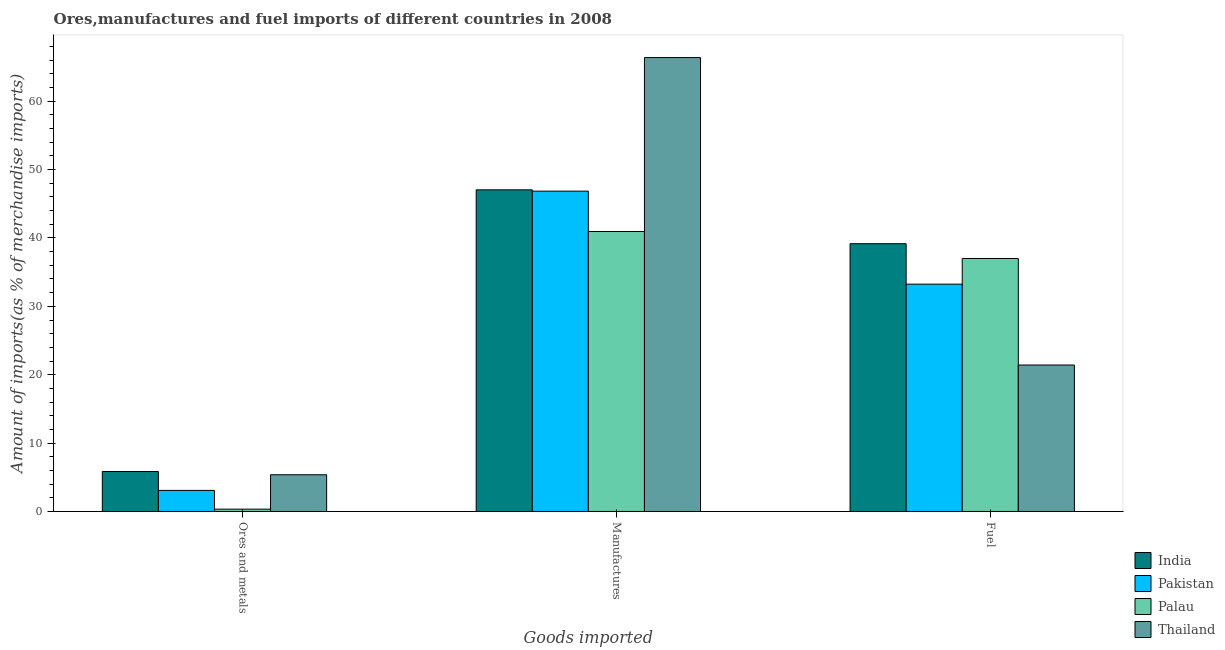How many groups of bars are there?
Offer a terse response. 3. Are the number of bars per tick equal to the number of legend labels?
Keep it short and to the point. Yes. How many bars are there on the 1st tick from the left?
Provide a short and direct response. 4. What is the label of the 1st group of bars from the left?
Give a very brief answer. Ores and metals. What is the percentage of fuel imports in India?
Your answer should be very brief. 39.16. Across all countries, what is the maximum percentage of manufactures imports?
Provide a succinct answer. 66.38. Across all countries, what is the minimum percentage of fuel imports?
Ensure brevity in your answer.  21.42. In which country was the percentage of ores and metals imports maximum?
Your response must be concise. India. In which country was the percentage of manufactures imports minimum?
Offer a very short reply. Palau. What is the total percentage of ores and metals imports in the graph?
Your response must be concise. 14.64. What is the difference between the percentage of manufactures imports in Pakistan and that in India?
Your response must be concise. -0.19. What is the difference between the percentage of fuel imports in Pakistan and the percentage of manufactures imports in Palau?
Offer a very short reply. -7.7. What is the average percentage of manufactures imports per country?
Ensure brevity in your answer.  50.31. What is the difference between the percentage of fuel imports and percentage of ores and metals imports in Palau?
Your answer should be very brief. 36.66. In how many countries, is the percentage of ores and metals imports greater than 22 %?
Keep it short and to the point. 0. What is the ratio of the percentage of fuel imports in Palau to that in Thailand?
Give a very brief answer. 1.73. Is the percentage of manufactures imports in Palau less than that in India?
Provide a short and direct response. Yes. What is the difference between the highest and the second highest percentage of fuel imports?
Your answer should be very brief. 2.16. What is the difference between the highest and the lowest percentage of manufactures imports?
Provide a succinct answer. 25.44. In how many countries, is the percentage of fuel imports greater than the average percentage of fuel imports taken over all countries?
Your answer should be very brief. 3. Is the sum of the percentage of ores and metals imports in Pakistan and India greater than the maximum percentage of manufactures imports across all countries?
Offer a very short reply. No. What does the 2nd bar from the left in Ores and metals represents?
Provide a succinct answer. Pakistan. What does the 3rd bar from the right in Manufactures represents?
Provide a succinct answer. Pakistan. How many bars are there?
Offer a very short reply. 12. How many countries are there in the graph?
Ensure brevity in your answer.  4. Does the graph contain any zero values?
Your answer should be compact. No. Where does the legend appear in the graph?
Provide a short and direct response. Bottom right. How are the legend labels stacked?
Your answer should be compact. Vertical. What is the title of the graph?
Keep it short and to the point. Ores,manufactures and fuel imports of different countries in 2008. Does "Rwanda" appear as one of the legend labels in the graph?
Your answer should be compact. No. What is the label or title of the X-axis?
Offer a very short reply. Goods imported. What is the label or title of the Y-axis?
Keep it short and to the point. Amount of imports(as % of merchandise imports). What is the Amount of imports(as % of merchandise imports) of India in Ores and metals?
Keep it short and to the point. 5.85. What is the Amount of imports(as % of merchandise imports) in Pakistan in Ores and metals?
Provide a short and direct response. 3.08. What is the Amount of imports(as % of merchandise imports) of Palau in Ores and metals?
Keep it short and to the point. 0.34. What is the Amount of imports(as % of merchandise imports) in Thailand in Ores and metals?
Your answer should be compact. 5.37. What is the Amount of imports(as % of merchandise imports) of India in Manufactures?
Offer a very short reply. 47.04. What is the Amount of imports(as % of merchandise imports) of Pakistan in Manufactures?
Ensure brevity in your answer.  46.85. What is the Amount of imports(as % of merchandise imports) in Palau in Manufactures?
Your answer should be very brief. 40.95. What is the Amount of imports(as % of merchandise imports) in Thailand in Manufactures?
Offer a terse response. 66.38. What is the Amount of imports(as % of merchandise imports) of India in Fuel?
Offer a terse response. 39.16. What is the Amount of imports(as % of merchandise imports) in Pakistan in Fuel?
Provide a succinct answer. 33.25. What is the Amount of imports(as % of merchandise imports) in Palau in Fuel?
Provide a short and direct response. 37. What is the Amount of imports(as % of merchandise imports) in Thailand in Fuel?
Provide a short and direct response. 21.42. Across all Goods imported, what is the maximum Amount of imports(as % of merchandise imports) in India?
Offer a terse response. 47.04. Across all Goods imported, what is the maximum Amount of imports(as % of merchandise imports) of Pakistan?
Offer a terse response. 46.85. Across all Goods imported, what is the maximum Amount of imports(as % of merchandise imports) of Palau?
Your answer should be very brief. 40.95. Across all Goods imported, what is the maximum Amount of imports(as % of merchandise imports) in Thailand?
Offer a very short reply. 66.38. Across all Goods imported, what is the minimum Amount of imports(as % of merchandise imports) of India?
Provide a short and direct response. 5.85. Across all Goods imported, what is the minimum Amount of imports(as % of merchandise imports) of Pakistan?
Ensure brevity in your answer.  3.08. Across all Goods imported, what is the minimum Amount of imports(as % of merchandise imports) in Palau?
Provide a short and direct response. 0.34. Across all Goods imported, what is the minimum Amount of imports(as % of merchandise imports) in Thailand?
Make the answer very short. 5.37. What is the total Amount of imports(as % of merchandise imports) in India in the graph?
Your answer should be very brief. 92.05. What is the total Amount of imports(as % of merchandise imports) in Pakistan in the graph?
Your answer should be very brief. 83.18. What is the total Amount of imports(as % of merchandise imports) of Palau in the graph?
Your response must be concise. 78.29. What is the total Amount of imports(as % of merchandise imports) of Thailand in the graph?
Your answer should be very brief. 93.17. What is the difference between the Amount of imports(as % of merchandise imports) of India in Ores and metals and that in Manufactures?
Keep it short and to the point. -41.19. What is the difference between the Amount of imports(as % of merchandise imports) in Pakistan in Ores and metals and that in Manufactures?
Offer a terse response. -43.77. What is the difference between the Amount of imports(as % of merchandise imports) in Palau in Ores and metals and that in Manufactures?
Ensure brevity in your answer.  -40.61. What is the difference between the Amount of imports(as % of merchandise imports) in Thailand in Ores and metals and that in Manufactures?
Give a very brief answer. -61.01. What is the difference between the Amount of imports(as % of merchandise imports) in India in Ores and metals and that in Fuel?
Provide a succinct answer. -33.32. What is the difference between the Amount of imports(as % of merchandise imports) of Pakistan in Ores and metals and that in Fuel?
Offer a very short reply. -30.16. What is the difference between the Amount of imports(as % of merchandise imports) in Palau in Ores and metals and that in Fuel?
Your response must be concise. -36.66. What is the difference between the Amount of imports(as % of merchandise imports) of Thailand in Ores and metals and that in Fuel?
Provide a succinct answer. -16.05. What is the difference between the Amount of imports(as % of merchandise imports) in India in Manufactures and that in Fuel?
Ensure brevity in your answer.  7.88. What is the difference between the Amount of imports(as % of merchandise imports) in Pakistan in Manufactures and that in Fuel?
Provide a short and direct response. 13.6. What is the difference between the Amount of imports(as % of merchandise imports) in Palau in Manufactures and that in Fuel?
Provide a short and direct response. 3.95. What is the difference between the Amount of imports(as % of merchandise imports) in Thailand in Manufactures and that in Fuel?
Keep it short and to the point. 44.96. What is the difference between the Amount of imports(as % of merchandise imports) of India in Ores and metals and the Amount of imports(as % of merchandise imports) of Pakistan in Manufactures?
Your response must be concise. -41. What is the difference between the Amount of imports(as % of merchandise imports) of India in Ores and metals and the Amount of imports(as % of merchandise imports) of Palau in Manufactures?
Provide a succinct answer. -35.1. What is the difference between the Amount of imports(as % of merchandise imports) in India in Ores and metals and the Amount of imports(as % of merchandise imports) in Thailand in Manufactures?
Your response must be concise. -60.54. What is the difference between the Amount of imports(as % of merchandise imports) in Pakistan in Ores and metals and the Amount of imports(as % of merchandise imports) in Palau in Manufactures?
Give a very brief answer. -37.86. What is the difference between the Amount of imports(as % of merchandise imports) of Pakistan in Ores and metals and the Amount of imports(as % of merchandise imports) of Thailand in Manufactures?
Provide a succinct answer. -63.3. What is the difference between the Amount of imports(as % of merchandise imports) of Palau in Ores and metals and the Amount of imports(as % of merchandise imports) of Thailand in Manufactures?
Provide a short and direct response. -66.04. What is the difference between the Amount of imports(as % of merchandise imports) in India in Ores and metals and the Amount of imports(as % of merchandise imports) in Pakistan in Fuel?
Provide a short and direct response. -27.4. What is the difference between the Amount of imports(as % of merchandise imports) of India in Ores and metals and the Amount of imports(as % of merchandise imports) of Palau in Fuel?
Offer a very short reply. -31.15. What is the difference between the Amount of imports(as % of merchandise imports) of India in Ores and metals and the Amount of imports(as % of merchandise imports) of Thailand in Fuel?
Ensure brevity in your answer.  -15.57. What is the difference between the Amount of imports(as % of merchandise imports) of Pakistan in Ores and metals and the Amount of imports(as % of merchandise imports) of Palau in Fuel?
Make the answer very short. -33.92. What is the difference between the Amount of imports(as % of merchandise imports) in Pakistan in Ores and metals and the Amount of imports(as % of merchandise imports) in Thailand in Fuel?
Keep it short and to the point. -18.33. What is the difference between the Amount of imports(as % of merchandise imports) in Palau in Ores and metals and the Amount of imports(as % of merchandise imports) in Thailand in Fuel?
Offer a terse response. -21.08. What is the difference between the Amount of imports(as % of merchandise imports) in India in Manufactures and the Amount of imports(as % of merchandise imports) in Pakistan in Fuel?
Give a very brief answer. 13.79. What is the difference between the Amount of imports(as % of merchandise imports) of India in Manufactures and the Amount of imports(as % of merchandise imports) of Palau in Fuel?
Offer a terse response. 10.04. What is the difference between the Amount of imports(as % of merchandise imports) in India in Manufactures and the Amount of imports(as % of merchandise imports) in Thailand in Fuel?
Offer a terse response. 25.62. What is the difference between the Amount of imports(as % of merchandise imports) in Pakistan in Manufactures and the Amount of imports(as % of merchandise imports) in Palau in Fuel?
Provide a short and direct response. 9.85. What is the difference between the Amount of imports(as % of merchandise imports) of Pakistan in Manufactures and the Amount of imports(as % of merchandise imports) of Thailand in Fuel?
Make the answer very short. 25.43. What is the difference between the Amount of imports(as % of merchandise imports) of Palau in Manufactures and the Amount of imports(as % of merchandise imports) of Thailand in Fuel?
Offer a terse response. 19.53. What is the average Amount of imports(as % of merchandise imports) in India per Goods imported?
Keep it short and to the point. 30.68. What is the average Amount of imports(as % of merchandise imports) in Pakistan per Goods imported?
Keep it short and to the point. 27.73. What is the average Amount of imports(as % of merchandise imports) of Palau per Goods imported?
Provide a short and direct response. 26.1. What is the average Amount of imports(as % of merchandise imports) in Thailand per Goods imported?
Ensure brevity in your answer.  31.06. What is the difference between the Amount of imports(as % of merchandise imports) in India and Amount of imports(as % of merchandise imports) in Pakistan in Ores and metals?
Offer a terse response. 2.76. What is the difference between the Amount of imports(as % of merchandise imports) in India and Amount of imports(as % of merchandise imports) in Palau in Ores and metals?
Keep it short and to the point. 5.5. What is the difference between the Amount of imports(as % of merchandise imports) of India and Amount of imports(as % of merchandise imports) of Thailand in Ores and metals?
Your answer should be compact. 0.48. What is the difference between the Amount of imports(as % of merchandise imports) in Pakistan and Amount of imports(as % of merchandise imports) in Palau in Ores and metals?
Keep it short and to the point. 2.74. What is the difference between the Amount of imports(as % of merchandise imports) of Pakistan and Amount of imports(as % of merchandise imports) of Thailand in Ores and metals?
Keep it short and to the point. -2.29. What is the difference between the Amount of imports(as % of merchandise imports) of Palau and Amount of imports(as % of merchandise imports) of Thailand in Ores and metals?
Your response must be concise. -5.03. What is the difference between the Amount of imports(as % of merchandise imports) of India and Amount of imports(as % of merchandise imports) of Pakistan in Manufactures?
Offer a terse response. 0.19. What is the difference between the Amount of imports(as % of merchandise imports) of India and Amount of imports(as % of merchandise imports) of Palau in Manufactures?
Your answer should be very brief. 6.09. What is the difference between the Amount of imports(as % of merchandise imports) in India and Amount of imports(as % of merchandise imports) in Thailand in Manufactures?
Keep it short and to the point. -19.34. What is the difference between the Amount of imports(as % of merchandise imports) of Pakistan and Amount of imports(as % of merchandise imports) of Palau in Manufactures?
Provide a succinct answer. 5.9. What is the difference between the Amount of imports(as % of merchandise imports) in Pakistan and Amount of imports(as % of merchandise imports) in Thailand in Manufactures?
Offer a very short reply. -19.53. What is the difference between the Amount of imports(as % of merchandise imports) of Palau and Amount of imports(as % of merchandise imports) of Thailand in Manufactures?
Your answer should be compact. -25.44. What is the difference between the Amount of imports(as % of merchandise imports) in India and Amount of imports(as % of merchandise imports) in Pakistan in Fuel?
Offer a very short reply. 5.92. What is the difference between the Amount of imports(as % of merchandise imports) of India and Amount of imports(as % of merchandise imports) of Palau in Fuel?
Make the answer very short. 2.16. What is the difference between the Amount of imports(as % of merchandise imports) in India and Amount of imports(as % of merchandise imports) in Thailand in Fuel?
Offer a very short reply. 17.75. What is the difference between the Amount of imports(as % of merchandise imports) of Pakistan and Amount of imports(as % of merchandise imports) of Palau in Fuel?
Make the answer very short. -3.75. What is the difference between the Amount of imports(as % of merchandise imports) in Pakistan and Amount of imports(as % of merchandise imports) in Thailand in Fuel?
Your response must be concise. 11.83. What is the difference between the Amount of imports(as % of merchandise imports) in Palau and Amount of imports(as % of merchandise imports) in Thailand in Fuel?
Your response must be concise. 15.58. What is the ratio of the Amount of imports(as % of merchandise imports) in India in Ores and metals to that in Manufactures?
Provide a succinct answer. 0.12. What is the ratio of the Amount of imports(as % of merchandise imports) of Pakistan in Ores and metals to that in Manufactures?
Give a very brief answer. 0.07. What is the ratio of the Amount of imports(as % of merchandise imports) of Palau in Ores and metals to that in Manufactures?
Provide a succinct answer. 0.01. What is the ratio of the Amount of imports(as % of merchandise imports) in Thailand in Ores and metals to that in Manufactures?
Your answer should be very brief. 0.08. What is the ratio of the Amount of imports(as % of merchandise imports) in India in Ores and metals to that in Fuel?
Keep it short and to the point. 0.15. What is the ratio of the Amount of imports(as % of merchandise imports) in Pakistan in Ores and metals to that in Fuel?
Provide a short and direct response. 0.09. What is the ratio of the Amount of imports(as % of merchandise imports) in Palau in Ores and metals to that in Fuel?
Give a very brief answer. 0.01. What is the ratio of the Amount of imports(as % of merchandise imports) in Thailand in Ores and metals to that in Fuel?
Provide a short and direct response. 0.25. What is the ratio of the Amount of imports(as % of merchandise imports) of India in Manufactures to that in Fuel?
Your answer should be very brief. 1.2. What is the ratio of the Amount of imports(as % of merchandise imports) of Pakistan in Manufactures to that in Fuel?
Ensure brevity in your answer.  1.41. What is the ratio of the Amount of imports(as % of merchandise imports) of Palau in Manufactures to that in Fuel?
Offer a terse response. 1.11. What is the ratio of the Amount of imports(as % of merchandise imports) of Thailand in Manufactures to that in Fuel?
Your response must be concise. 3.1. What is the difference between the highest and the second highest Amount of imports(as % of merchandise imports) of India?
Your answer should be very brief. 7.88. What is the difference between the highest and the second highest Amount of imports(as % of merchandise imports) of Pakistan?
Offer a terse response. 13.6. What is the difference between the highest and the second highest Amount of imports(as % of merchandise imports) of Palau?
Offer a very short reply. 3.95. What is the difference between the highest and the second highest Amount of imports(as % of merchandise imports) in Thailand?
Your response must be concise. 44.96. What is the difference between the highest and the lowest Amount of imports(as % of merchandise imports) of India?
Ensure brevity in your answer.  41.19. What is the difference between the highest and the lowest Amount of imports(as % of merchandise imports) in Pakistan?
Your answer should be compact. 43.77. What is the difference between the highest and the lowest Amount of imports(as % of merchandise imports) in Palau?
Ensure brevity in your answer.  40.61. What is the difference between the highest and the lowest Amount of imports(as % of merchandise imports) in Thailand?
Keep it short and to the point. 61.01. 